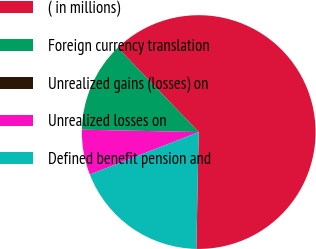Convert chart to OTSL. <chart><loc_0><loc_0><loc_500><loc_500><pie_chart><fcel>( in millions)<fcel>Foreign currency translation<fcel>Unrealized gains (losses) on<fcel>Unrealized losses on<fcel>Defined benefit pension and<nl><fcel>62.49%<fcel>12.5%<fcel>0.0%<fcel>6.25%<fcel>18.75%<nl></chart> 